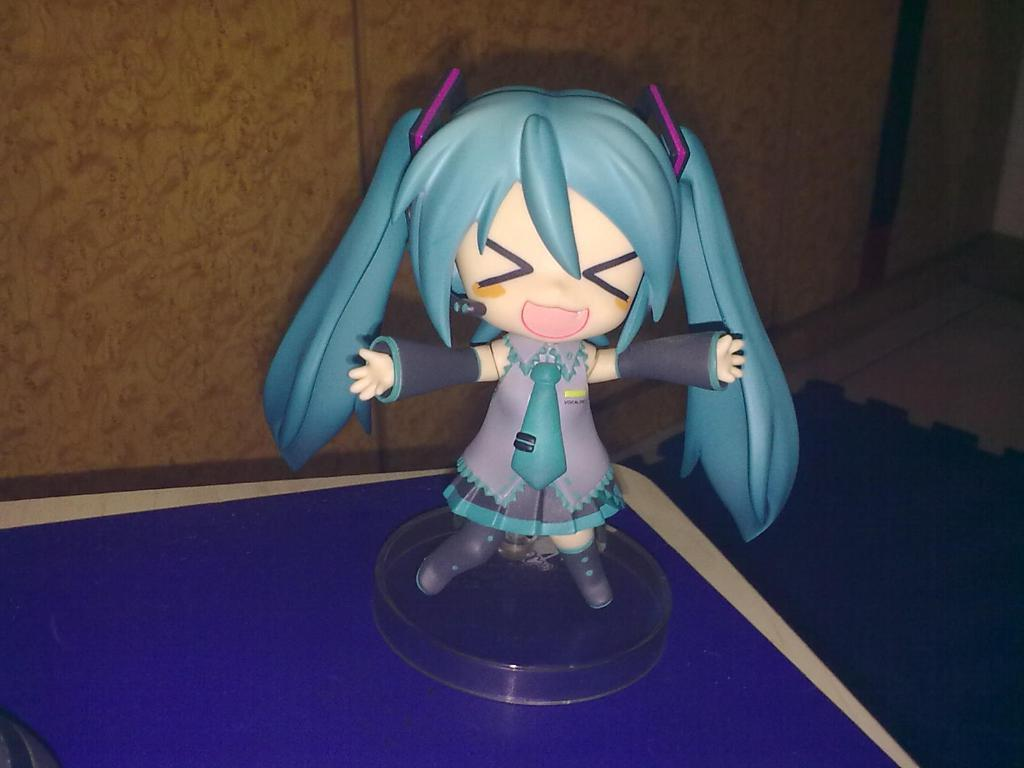What is the main subject in the foreground of the image? There is a toy statue in the foreground of the image. What color is the surface on which the toy statue is placed? The toy statue is on a blue surface. What can be seen in the background of the image? There is a wall and a floor in the background of the image. Are there any objects on the floor in the background? Yes, there is an object on the floor in the background of the image. Can you tell me how many yaks are crossing the bridge in the image? There is no bridge or yaks present in the image. What type of lunch is being served on the floor in the image? There is no lunch present in the image; it features a toy statue on a blue surface with a wall and floor in the background. 